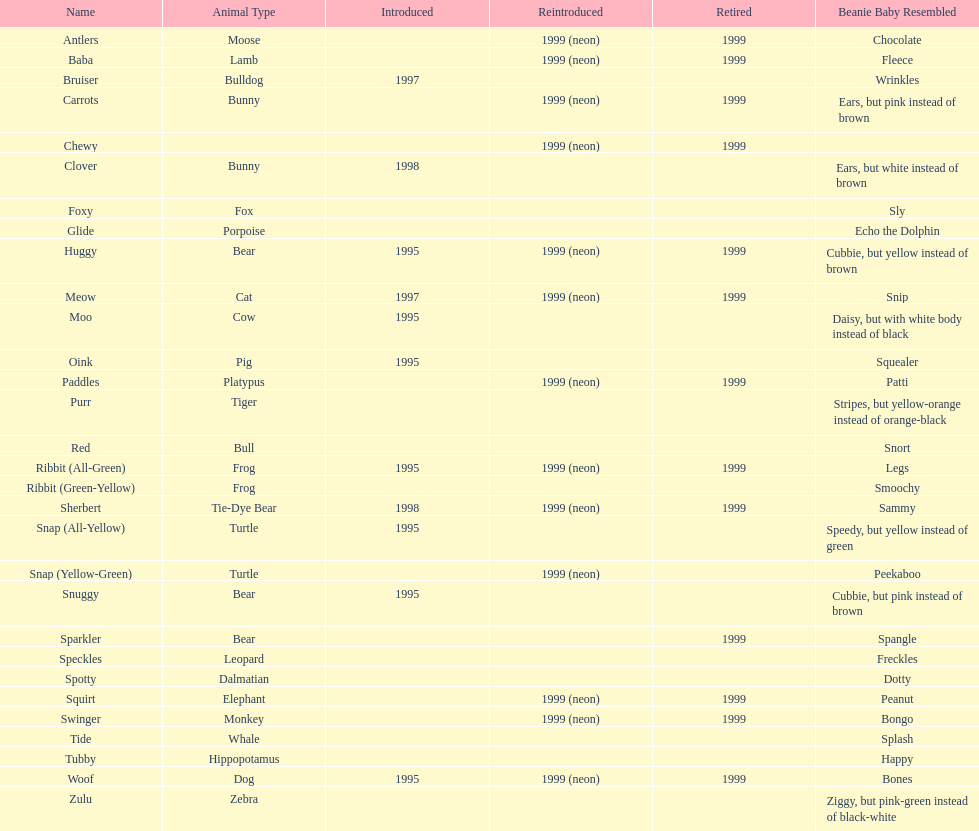What is the only dalmatian pillow pal called? Spotty. 